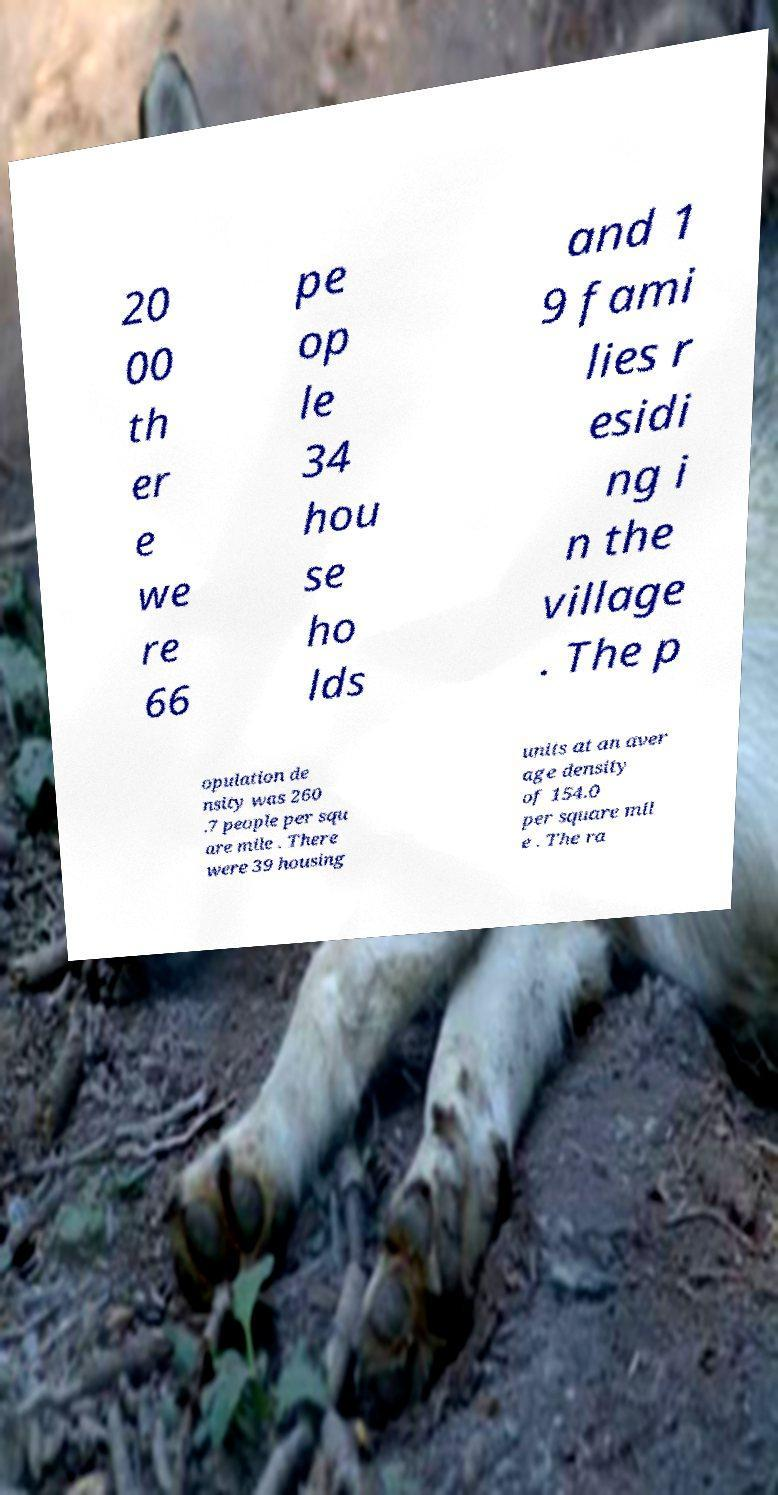I need the written content from this picture converted into text. Can you do that? 20 00 th er e we re 66 pe op le 34 hou se ho lds and 1 9 fami lies r esidi ng i n the village . The p opulation de nsity was 260 .7 people per squ are mile . There were 39 housing units at an aver age density of 154.0 per square mil e . The ra 